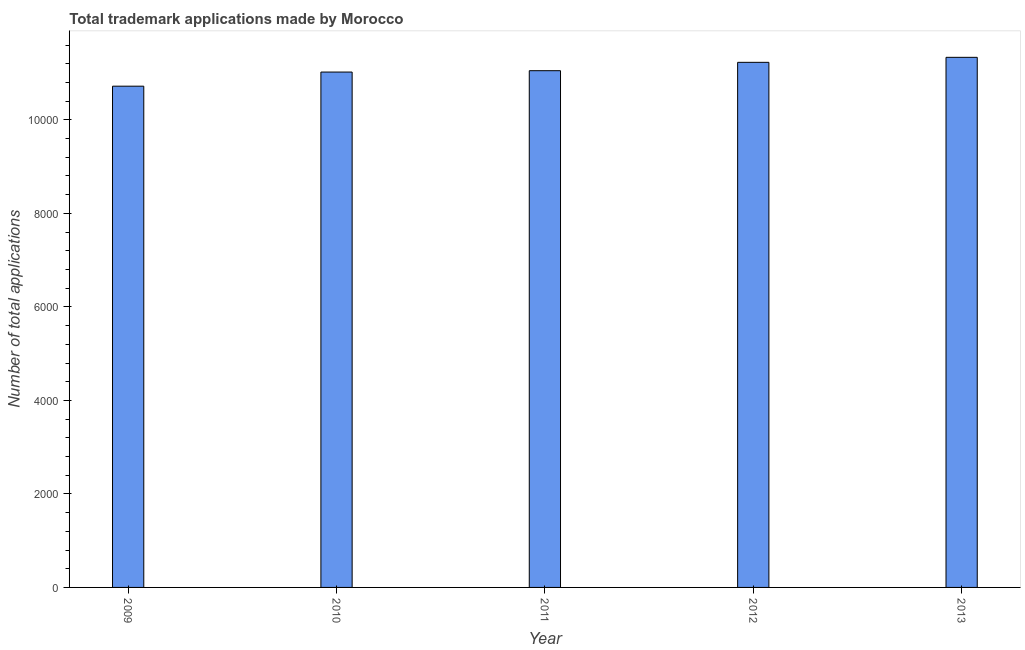Does the graph contain any zero values?
Provide a short and direct response. No. Does the graph contain grids?
Provide a succinct answer. No. What is the title of the graph?
Make the answer very short. Total trademark applications made by Morocco. What is the label or title of the X-axis?
Provide a short and direct response. Year. What is the label or title of the Y-axis?
Your response must be concise. Number of total applications. What is the number of trademark applications in 2010?
Offer a very short reply. 1.10e+04. Across all years, what is the maximum number of trademark applications?
Your response must be concise. 1.13e+04. Across all years, what is the minimum number of trademark applications?
Make the answer very short. 1.07e+04. In which year was the number of trademark applications maximum?
Your response must be concise. 2013. In which year was the number of trademark applications minimum?
Your answer should be compact. 2009. What is the sum of the number of trademark applications?
Offer a very short reply. 5.54e+04. What is the difference between the number of trademark applications in 2009 and 2011?
Provide a succinct answer. -331. What is the average number of trademark applications per year?
Keep it short and to the point. 1.11e+04. What is the median number of trademark applications?
Your answer should be compact. 1.11e+04. In how many years, is the number of trademark applications greater than 2400 ?
Provide a succinct answer. 5. What is the ratio of the number of trademark applications in 2009 to that in 2013?
Keep it short and to the point. 0.95. Is the number of trademark applications in 2011 less than that in 2013?
Make the answer very short. Yes. Is the difference between the number of trademark applications in 2009 and 2011 greater than the difference between any two years?
Your answer should be very brief. No. What is the difference between the highest and the second highest number of trademark applications?
Provide a succinct answer. 107. What is the difference between the highest and the lowest number of trademark applications?
Your answer should be compact. 617. How many bars are there?
Offer a terse response. 5. How many years are there in the graph?
Provide a succinct answer. 5. What is the Number of total applications in 2009?
Give a very brief answer. 1.07e+04. What is the Number of total applications of 2010?
Your answer should be very brief. 1.10e+04. What is the Number of total applications of 2011?
Your answer should be compact. 1.11e+04. What is the Number of total applications in 2012?
Offer a terse response. 1.12e+04. What is the Number of total applications of 2013?
Provide a succinct answer. 1.13e+04. What is the difference between the Number of total applications in 2009 and 2010?
Offer a very short reply. -302. What is the difference between the Number of total applications in 2009 and 2011?
Offer a very short reply. -331. What is the difference between the Number of total applications in 2009 and 2012?
Ensure brevity in your answer.  -510. What is the difference between the Number of total applications in 2009 and 2013?
Offer a terse response. -617. What is the difference between the Number of total applications in 2010 and 2011?
Provide a succinct answer. -29. What is the difference between the Number of total applications in 2010 and 2012?
Provide a succinct answer. -208. What is the difference between the Number of total applications in 2010 and 2013?
Provide a short and direct response. -315. What is the difference between the Number of total applications in 2011 and 2012?
Give a very brief answer. -179. What is the difference between the Number of total applications in 2011 and 2013?
Offer a very short reply. -286. What is the difference between the Number of total applications in 2012 and 2013?
Keep it short and to the point. -107. What is the ratio of the Number of total applications in 2009 to that in 2012?
Make the answer very short. 0.95. What is the ratio of the Number of total applications in 2009 to that in 2013?
Provide a succinct answer. 0.95. What is the ratio of the Number of total applications in 2010 to that in 2013?
Make the answer very short. 0.97. 